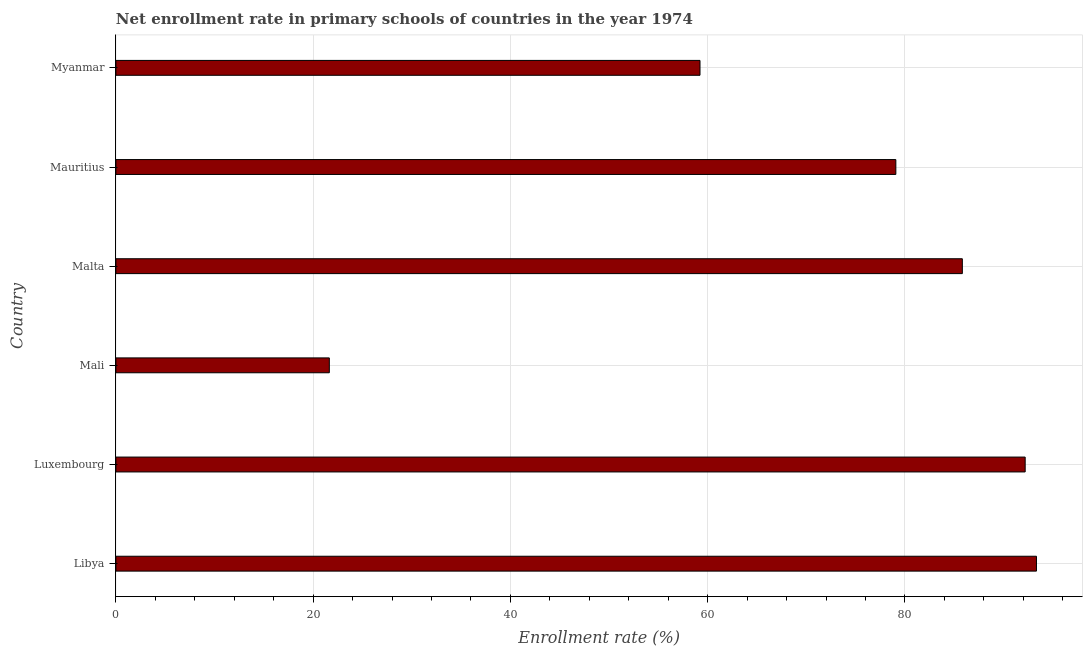Does the graph contain grids?
Make the answer very short. Yes. What is the title of the graph?
Offer a terse response. Net enrollment rate in primary schools of countries in the year 1974. What is the label or title of the X-axis?
Make the answer very short. Enrollment rate (%). What is the label or title of the Y-axis?
Ensure brevity in your answer.  Country. What is the net enrollment rate in primary schools in Luxembourg?
Your response must be concise. 92.19. Across all countries, what is the maximum net enrollment rate in primary schools?
Make the answer very short. 93.34. Across all countries, what is the minimum net enrollment rate in primary schools?
Ensure brevity in your answer.  21.64. In which country was the net enrollment rate in primary schools maximum?
Give a very brief answer. Libya. In which country was the net enrollment rate in primary schools minimum?
Give a very brief answer. Mali. What is the sum of the net enrollment rate in primary schools?
Offer a very short reply. 431.29. What is the difference between the net enrollment rate in primary schools in Mali and Myanmar?
Your response must be concise. -37.58. What is the average net enrollment rate in primary schools per country?
Provide a short and direct response. 71.88. What is the median net enrollment rate in primary schools?
Provide a succinct answer. 82.45. What is the ratio of the net enrollment rate in primary schools in Luxembourg to that in Mauritius?
Your response must be concise. 1.17. Is the net enrollment rate in primary schools in Luxembourg less than that in Mali?
Offer a very short reply. No. Is the difference between the net enrollment rate in primary schools in Malta and Mauritius greater than the difference between any two countries?
Provide a succinct answer. No. What is the difference between the highest and the second highest net enrollment rate in primary schools?
Offer a terse response. 1.15. What is the difference between the highest and the lowest net enrollment rate in primary schools?
Your response must be concise. 71.7. In how many countries, is the net enrollment rate in primary schools greater than the average net enrollment rate in primary schools taken over all countries?
Offer a terse response. 4. How many bars are there?
Give a very brief answer. 6. How many countries are there in the graph?
Offer a very short reply. 6. What is the Enrollment rate (%) in Libya?
Make the answer very short. 93.34. What is the Enrollment rate (%) of Luxembourg?
Make the answer very short. 92.19. What is the Enrollment rate (%) of Mali?
Make the answer very short. 21.64. What is the Enrollment rate (%) in Malta?
Your answer should be compact. 85.82. What is the Enrollment rate (%) in Mauritius?
Your response must be concise. 79.08. What is the Enrollment rate (%) of Myanmar?
Ensure brevity in your answer.  59.22. What is the difference between the Enrollment rate (%) in Libya and Luxembourg?
Keep it short and to the point. 1.14. What is the difference between the Enrollment rate (%) in Libya and Mali?
Offer a terse response. 71.7. What is the difference between the Enrollment rate (%) in Libya and Malta?
Your response must be concise. 7.51. What is the difference between the Enrollment rate (%) in Libya and Mauritius?
Ensure brevity in your answer.  14.26. What is the difference between the Enrollment rate (%) in Libya and Myanmar?
Ensure brevity in your answer.  34.11. What is the difference between the Enrollment rate (%) in Luxembourg and Mali?
Ensure brevity in your answer.  70.55. What is the difference between the Enrollment rate (%) in Luxembourg and Malta?
Offer a very short reply. 6.37. What is the difference between the Enrollment rate (%) in Luxembourg and Mauritius?
Keep it short and to the point. 13.11. What is the difference between the Enrollment rate (%) in Luxembourg and Myanmar?
Give a very brief answer. 32.97. What is the difference between the Enrollment rate (%) in Mali and Malta?
Offer a very short reply. -64.18. What is the difference between the Enrollment rate (%) in Mali and Mauritius?
Keep it short and to the point. -57.44. What is the difference between the Enrollment rate (%) in Mali and Myanmar?
Provide a succinct answer. -37.58. What is the difference between the Enrollment rate (%) in Malta and Mauritius?
Offer a terse response. 6.74. What is the difference between the Enrollment rate (%) in Malta and Myanmar?
Your response must be concise. 26.6. What is the difference between the Enrollment rate (%) in Mauritius and Myanmar?
Make the answer very short. 19.86. What is the ratio of the Enrollment rate (%) in Libya to that in Mali?
Give a very brief answer. 4.31. What is the ratio of the Enrollment rate (%) in Libya to that in Malta?
Provide a short and direct response. 1.09. What is the ratio of the Enrollment rate (%) in Libya to that in Mauritius?
Give a very brief answer. 1.18. What is the ratio of the Enrollment rate (%) in Libya to that in Myanmar?
Provide a succinct answer. 1.58. What is the ratio of the Enrollment rate (%) in Luxembourg to that in Mali?
Your response must be concise. 4.26. What is the ratio of the Enrollment rate (%) in Luxembourg to that in Malta?
Your answer should be compact. 1.07. What is the ratio of the Enrollment rate (%) in Luxembourg to that in Mauritius?
Offer a terse response. 1.17. What is the ratio of the Enrollment rate (%) in Luxembourg to that in Myanmar?
Offer a very short reply. 1.56. What is the ratio of the Enrollment rate (%) in Mali to that in Malta?
Give a very brief answer. 0.25. What is the ratio of the Enrollment rate (%) in Mali to that in Mauritius?
Ensure brevity in your answer.  0.27. What is the ratio of the Enrollment rate (%) in Mali to that in Myanmar?
Ensure brevity in your answer.  0.36. What is the ratio of the Enrollment rate (%) in Malta to that in Mauritius?
Your response must be concise. 1.08. What is the ratio of the Enrollment rate (%) in Malta to that in Myanmar?
Your answer should be compact. 1.45. What is the ratio of the Enrollment rate (%) in Mauritius to that in Myanmar?
Your response must be concise. 1.33. 